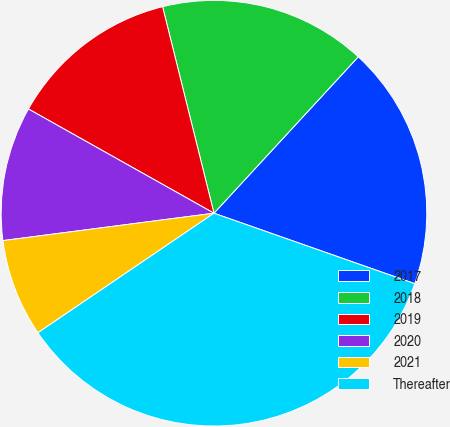<chart> <loc_0><loc_0><loc_500><loc_500><pie_chart><fcel>2017<fcel>2018<fcel>2019<fcel>2020<fcel>2021<fcel>Thereafter<nl><fcel>18.51%<fcel>15.74%<fcel>12.97%<fcel>10.2%<fcel>7.44%<fcel>35.13%<nl></chart> 